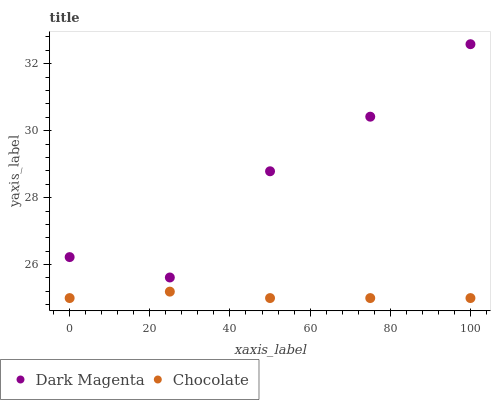Does Chocolate have the minimum area under the curve?
Answer yes or no. Yes. Does Dark Magenta have the maximum area under the curve?
Answer yes or no. Yes. Does Chocolate have the maximum area under the curve?
Answer yes or no. No. Is Chocolate the smoothest?
Answer yes or no. Yes. Is Dark Magenta the roughest?
Answer yes or no. Yes. Is Chocolate the roughest?
Answer yes or no. No. Does Chocolate have the lowest value?
Answer yes or no. Yes. Does Dark Magenta have the highest value?
Answer yes or no. Yes. Does Chocolate have the highest value?
Answer yes or no. No. Is Chocolate less than Dark Magenta?
Answer yes or no. Yes. Is Dark Magenta greater than Chocolate?
Answer yes or no. Yes. Does Chocolate intersect Dark Magenta?
Answer yes or no. No. 